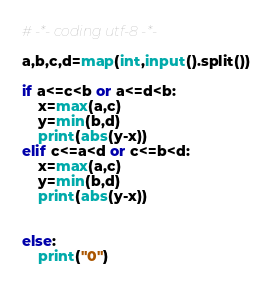Convert code to text. <code><loc_0><loc_0><loc_500><loc_500><_Python_># -*- coding utf-8 -*-

a,b,c,d=map(int,input().split())

if a<=c<b or a<=d<b:
    x=max(a,c)
    y=min(b,d)
    print(abs(y-x))
elif c<=a<d or c<=b<d:
    x=max(a,c)
    y=min(b,d)
    print(abs(y-x))


else:
    print("0")
</code> 